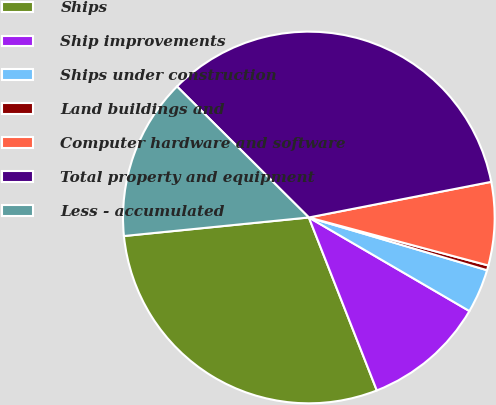Convert chart to OTSL. <chart><loc_0><loc_0><loc_500><loc_500><pie_chart><fcel>Ships<fcel>Ship improvements<fcel>Ships under construction<fcel>Land buildings and<fcel>Computer hardware and software<fcel>Total property and equipment<fcel>Less - accumulated<nl><fcel>29.37%<fcel>10.64%<fcel>3.82%<fcel>0.42%<fcel>7.23%<fcel>34.48%<fcel>14.04%<nl></chart> 